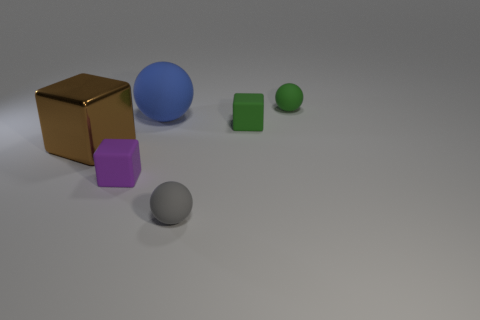Is there a green thing that has the same size as the purple object?
Your response must be concise. Yes. There is a block that is the same size as the blue matte thing; what is it made of?
Offer a terse response. Metal. How many objects are either small cubes that are to the right of the blue rubber ball or matte objects behind the large matte sphere?
Ensure brevity in your answer.  2. Is there another small gray object that has the same shape as the gray rubber thing?
Give a very brief answer. No. What number of matte things are large brown cubes or large blue things?
Give a very brief answer. 1. The big brown thing has what shape?
Provide a succinct answer. Cube. What number of small blocks are made of the same material as the blue thing?
Offer a terse response. 2. There is a large ball that is the same material as the small gray thing; what is its color?
Offer a terse response. Blue. There is a green thing that is in front of the green rubber ball; is it the same size as the purple thing?
Give a very brief answer. Yes. What color is the metal object that is the same shape as the tiny purple rubber object?
Provide a short and direct response. Brown. 